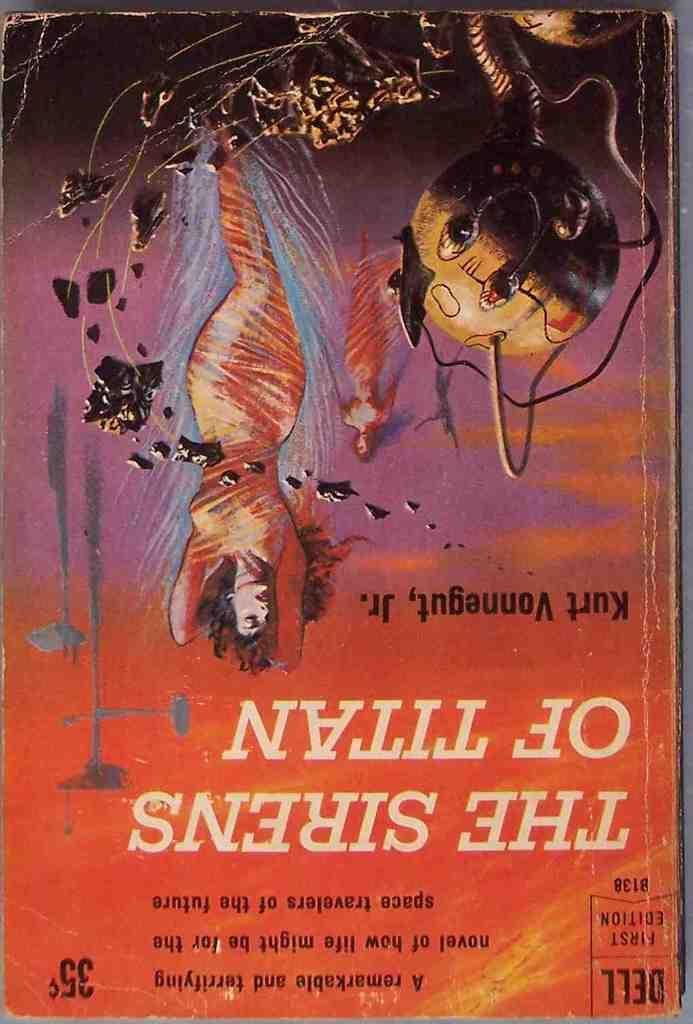What is the main subject of the image? The main subject of the image is a book cover. What can be seen on the book cover? There is a person depicted on the book cover, along with objects and text. What is the appearance of the book cover? The book cover is colorful. How many kittens are playing with a feather on the book cover? There are no kittens or feathers present on the book cover; it features a person, objects, and text. What type of transport is shown on the book cover? There is no transport depicted on the book cover; it only features a person, objects, and text. 